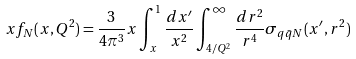<formula> <loc_0><loc_0><loc_500><loc_500>x f _ { N } ( x , Q ^ { 2 } ) = \frac { 3 } { 4 \pi ^ { 3 } } x \int _ { x } ^ { 1 } \frac { d x ^ { \prime } } { x ^ { 2 } } \int _ { 4 / Q ^ { 2 } } ^ { \infty } \frac { d r ^ { 2 } } { r ^ { 4 } } \sigma _ { q \bar { q } N } ( x ^ { \prime } , r ^ { 2 } )</formula> 